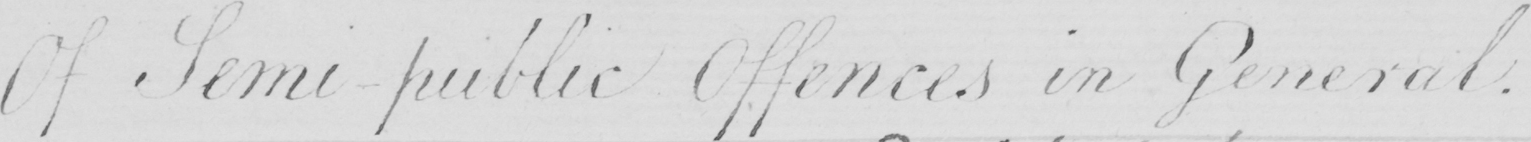Please transcribe the handwritten text in this image. Of Semi-public Offences in General . 